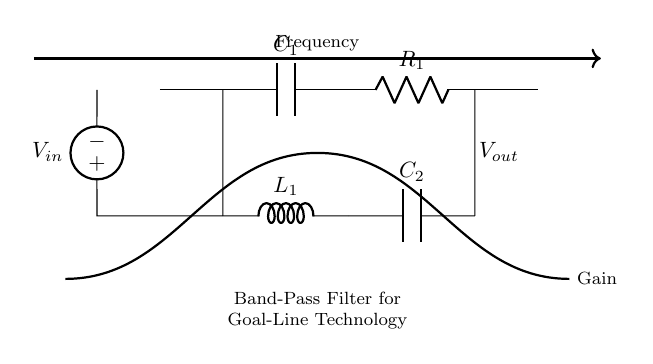What type of filter is this circuit? This circuit is designed as a band-pass filter, which allows a specific range of frequencies to pass while attenuating others. This is indicated by the combination of capacitors and inductors in the configuration.
Answer: Band-pass filter What is the input voltage source labeled as? The input voltage source is labeled as V-in, which indicates the point where the input signal is applied to the circuit. This information is visible at the left side of the circuit diagram.
Answer: V-in How many components are there in this filter circuit? There are five components in total: two capacitors, one inductor, one resistor, and one voltage source. This can be counted directly from the diagram, identifying each component by its label.
Answer: Five What are the labels of the capacitors in the circuit? The capacitors in the circuit are labeled as C-1 and C-2. This information can be found next to the symbols representing the capacitors in the circuit diagram.
Answer: C-1, C-2 What is the role of the inductor in this circuit? The inductor, labeled as L-1, plays a key role in tuning the frequency response of the filter, helping to define the passband together with the capacitors. This is fundamental in a band-pass filter, making the inductor essential for performance.
Answer: Define passband What is the output of this filter circuit labeled as? The output of this filter circuit is labeled as V-out, indicating the point where the filtered signal can be taken from the circuit. This is shown at the right end of the circuit diagram.
Answer: V-out Which components influence the cutoff frequencies in this filter? The cutoff frequencies are influenced by the capacitors C-1, C-2, and the inductor L-1, as their values determine where the filter starts attenuating frequencies outside the desired band. This is fundamental to the design of band-pass filters.
Answer: C-1, C-2, L-1 